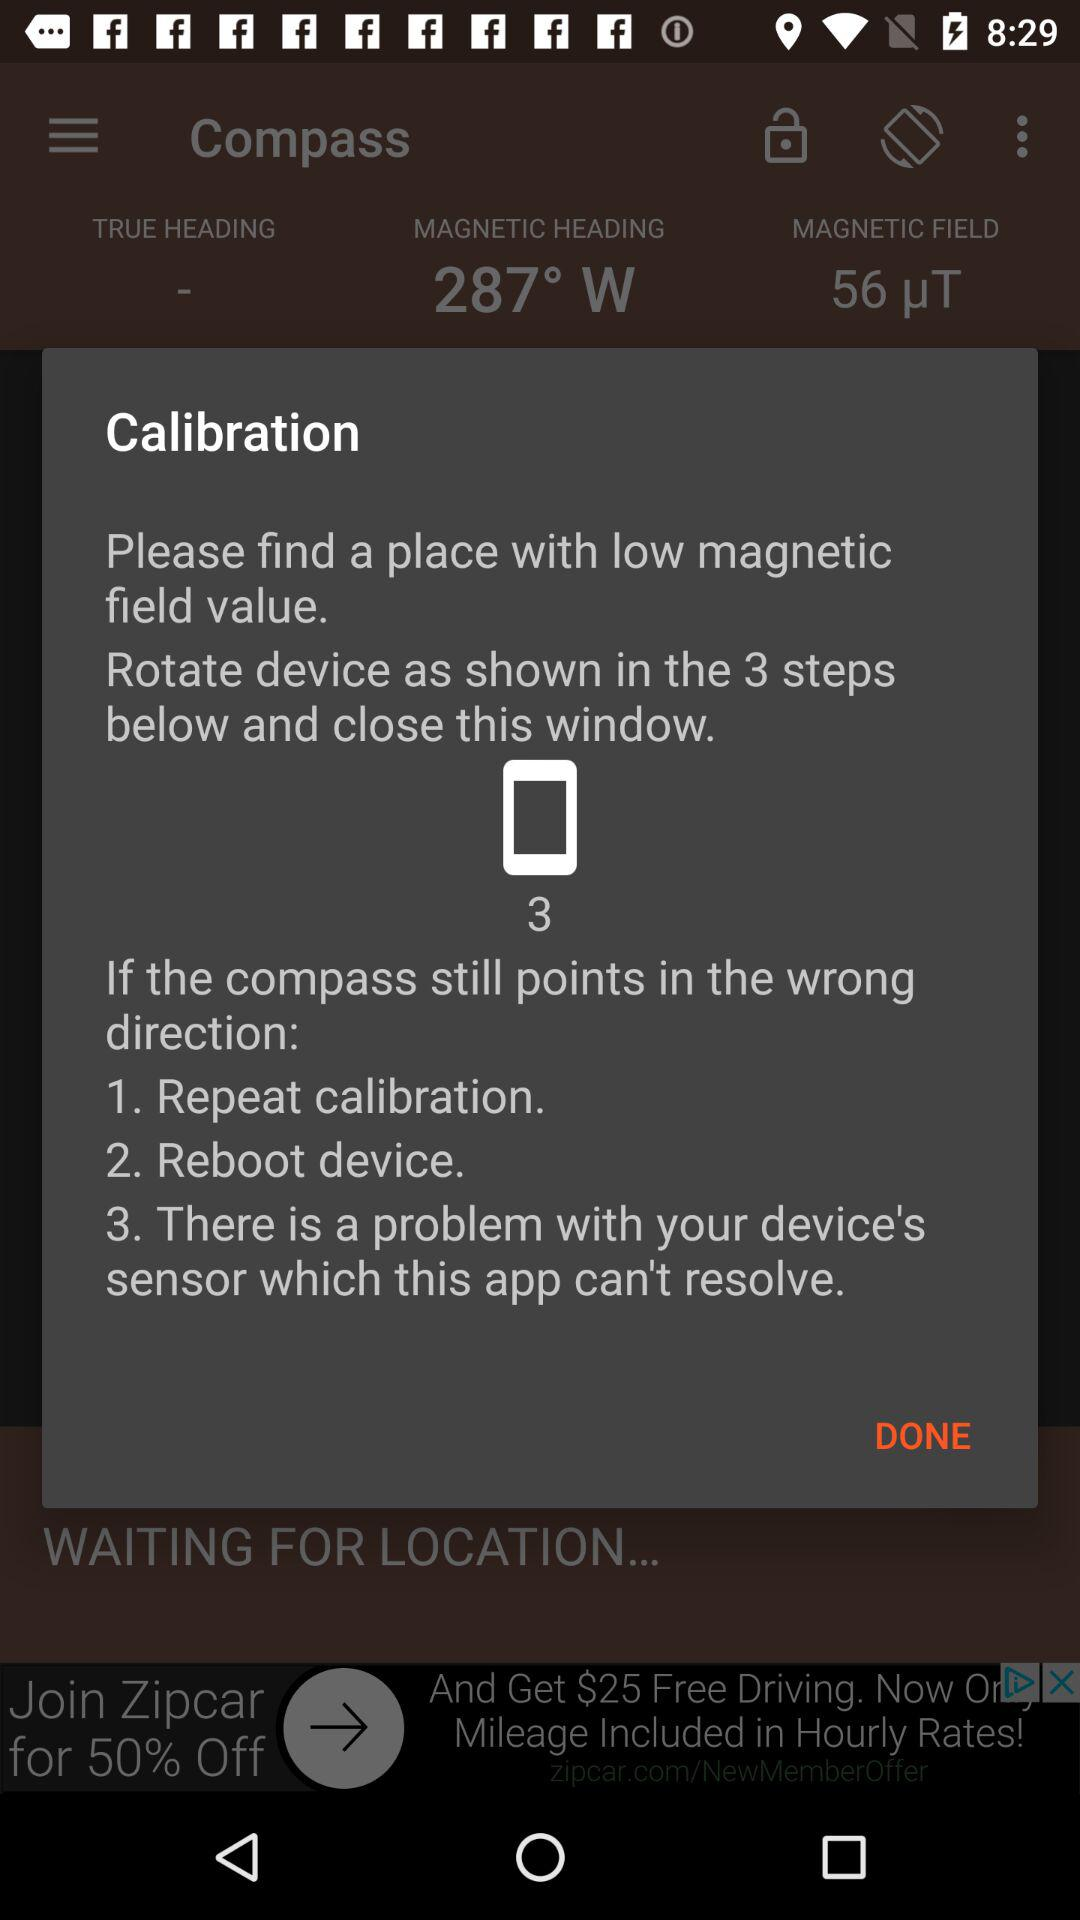How many steps are there in the calibration process?
Answer the question using a single word or phrase. 3 